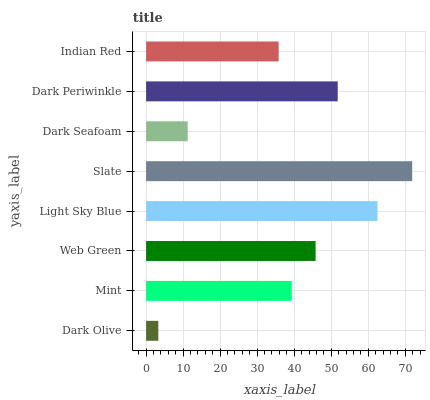Is Dark Olive the minimum?
Answer yes or no. Yes. Is Slate the maximum?
Answer yes or no. Yes. Is Mint the minimum?
Answer yes or no. No. Is Mint the maximum?
Answer yes or no. No. Is Mint greater than Dark Olive?
Answer yes or no. Yes. Is Dark Olive less than Mint?
Answer yes or no. Yes. Is Dark Olive greater than Mint?
Answer yes or no. No. Is Mint less than Dark Olive?
Answer yes or no. No. Is Web Green the high median?
Answer yes or no. Yes. Is Mint the low median?
Answer yes or no. Yes. Is Dark Seafoam the high median?
Answer yes or no. No. Is Dark Seafoam the low median?
Answer yes or no. No. 